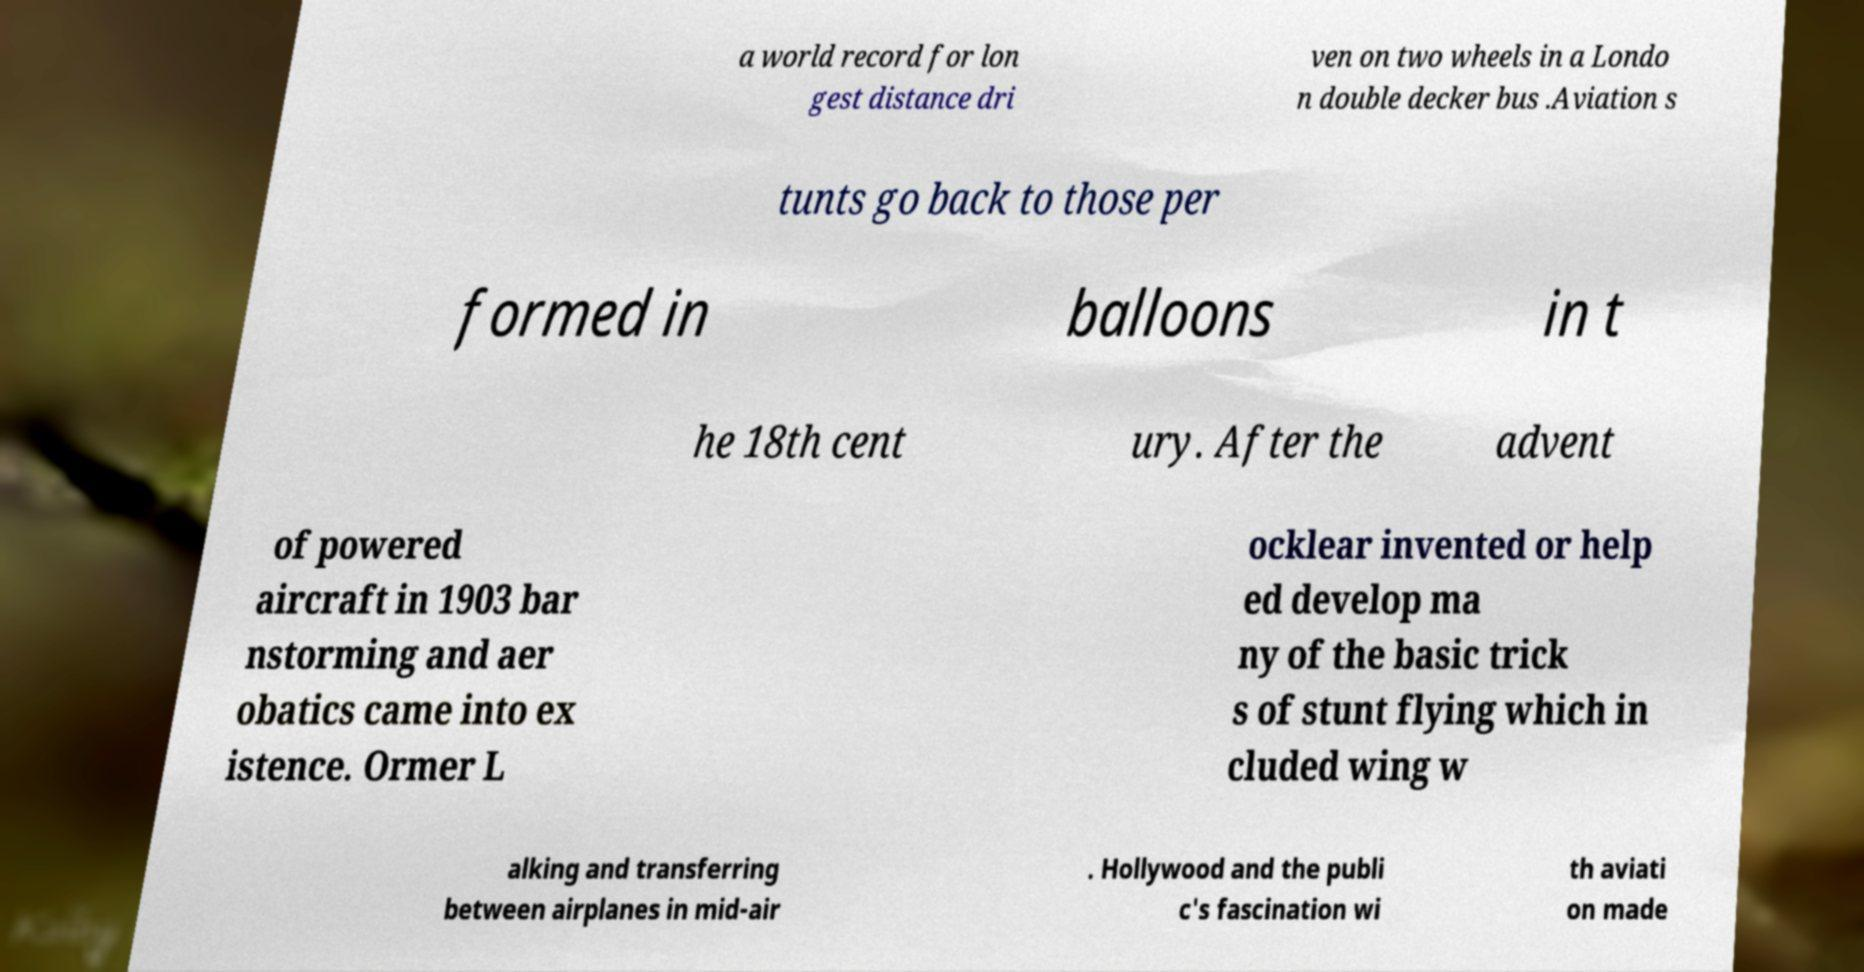Can you accurately transcribe the text from the provided image for me? a world record for lon gest distance dri ven on two wheels in a Londo n double decker bus .Aviation s tunts go back to those per formed in balloons in t he 18th cent ury. After the advent of powered aircraft in 1903 bar nstorming and aer obatics came into ex istence. Ormer L ocklear invented or help ed develop ma ny of the basic trick s of stunt flying which in cluded wing w alking and transferring between airplanes in mid-air . Hollywood and the publi c's fascination wi th aviati on made 